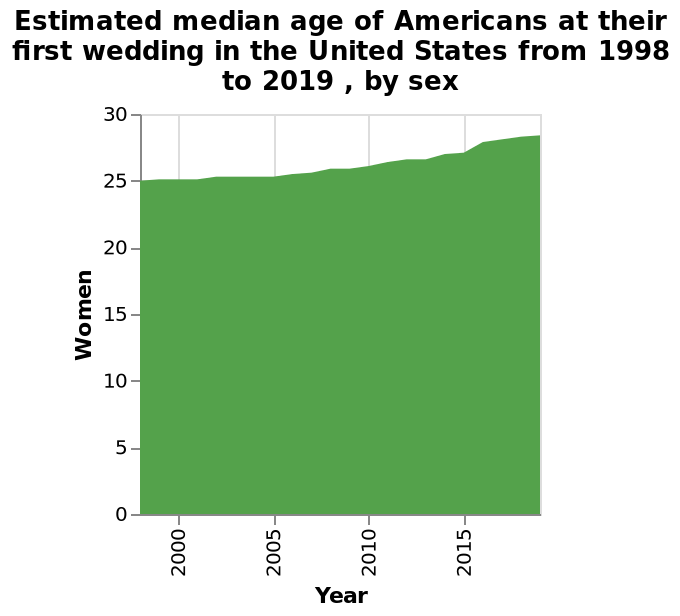<image>
Did the median age for women getting married remain the same between 1998 and 2005? Yes, the median age remained unchanged during that period. 